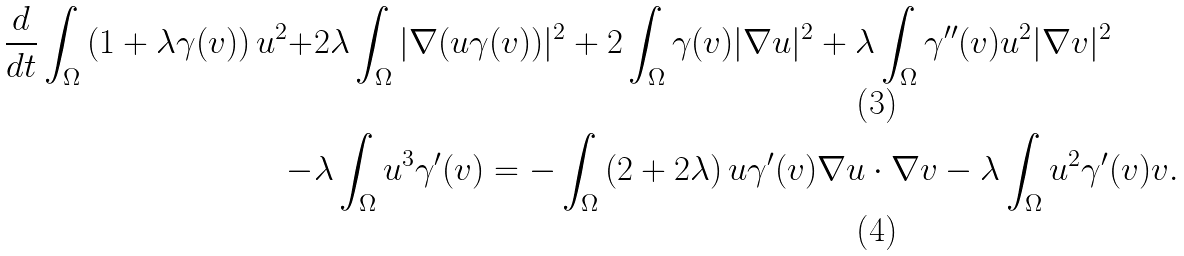Convert formula to latex. <formula><loc_0><loc_0><loc_500><loc_500>\frac { d } { d t } \int _ { \Omega } \left ( 1 + \lambda \gamma ( v ) \right ) u ^ { 2 } + & 2 \lambda \int _ { \Omega } | \nabla ( u \gamma ( v ) ) | ^ { 2 } + 2 \int _ { \Omega } \gamma ( v ) | \nabla u | ^ { 2 } + \lambda \int _ { \Omega } \gamma ^ { \prime \prime } ( v ) u ^ { 2 } | \nabla v | ^ { 2 } \\ - & \lambda \int _ { \Omega } u ^ { 3 } \gamma ^ { \prime } ( v ) = - \int _ { \Omega } \left ( 2 + 2 \lambda \right ) u \gamma ^ { \prime } ( v ) \nabla u \cdot \nabla v - \lambda \int _ { \Omega } u ^ { 2 } \gamma ^ { \prime } ( v ) v .</formula> 